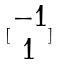Convert formula to latex. <formula><loc_0><loc_0><loc_500><loc_500>[ \begin{matrix} - 1 \\ 1 \end{matrix} ]</formula> 